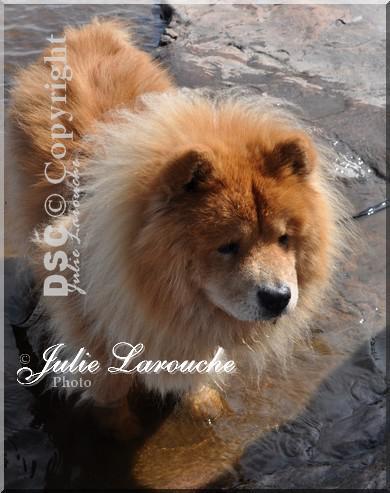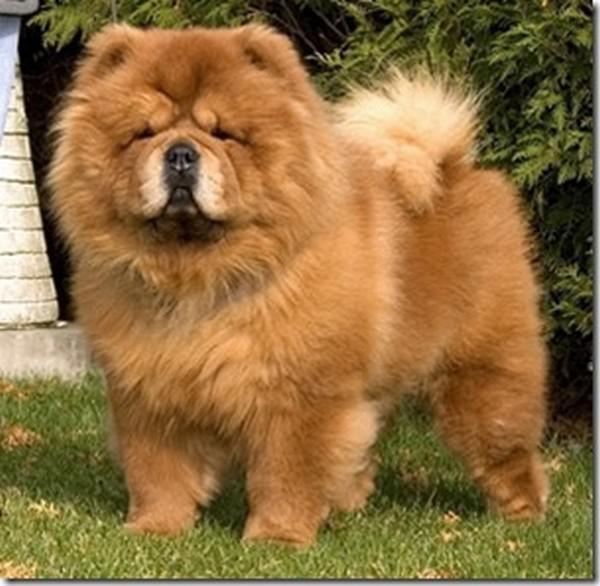The first image is the image on the left, the second image is the image on the right. For the images shown, is this caption "You can see one dog's feet in the grass." true? Answer yes or no. Yes. The first image is the image on the left, the second image is the image on the right. Evaluate the accuracy of this statement regarding the images: "One of the dogs is on a leash outdoors, in front of a leg clad in pants.". Is it true? Answer yes or no. No. 